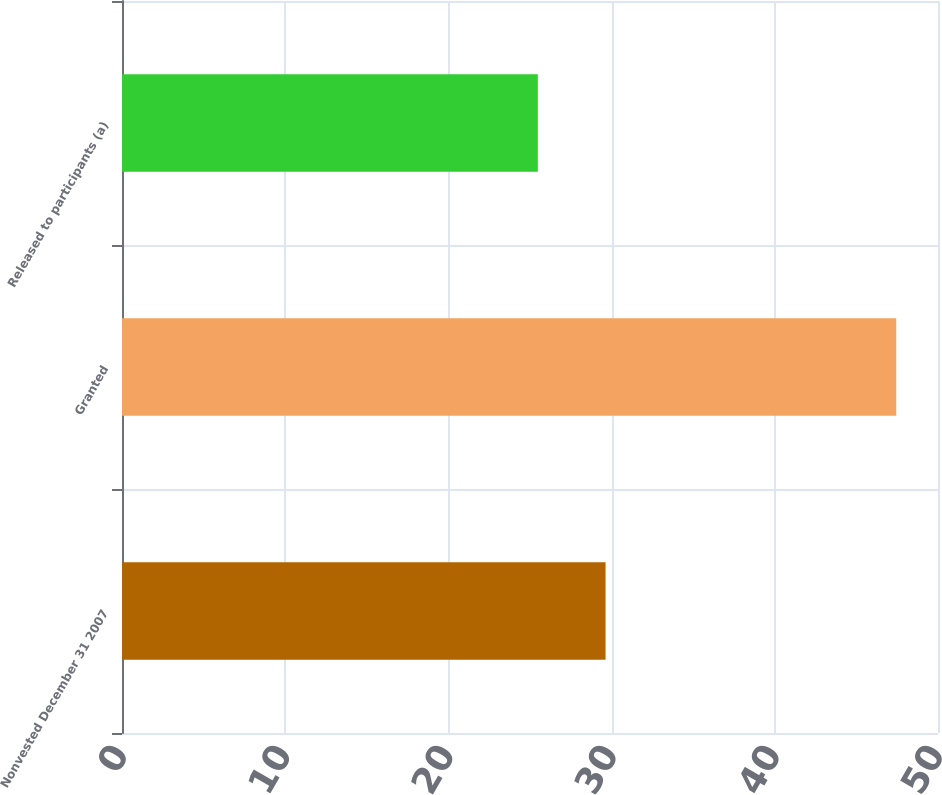Convert chart to OTSL. <chart><loc_0><loc_0><loc_500><loc_500><bar_chart><fcel>Nonvested December 31 2007<fcel>Granted<fcel>Released to participants (a)<nl><fcel>29.63<fcel>47.44<fcel>25.48<nl></chart> 